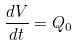<formula> <loc_0><loc_0><loc_500><loc_500>\frac { d V } { d t } = Q _ { 0 }</formula> 